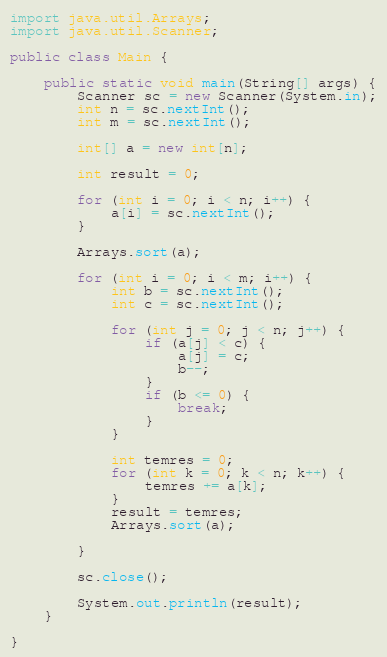Convert code to text. <code><loc_0><loc_0><loc_500><loc_500><_Java_>import java.util.Arrays;
import java.util.Scanner;

public class Main {

	public static void main(String[] args) {
		Scanner sc = new Scanner(System.in);
		int n = sc.nextInt();
		int m = sc.nextInt();

		int[] a = new int[n];

		int result = 0;

		for (int i = 0; i < n; i++) {
			a[i] = sc.nextInt();
		}

		Arrays.sort(a);

		for (int i = 0; i < m; i++) {
			int b = sc.nextInt();
			int c = sc.nextInt();

			for (int j = 0; j < n; j++) {
				if (a[j] < c) {
					a[j] = c;
					b--;
				}
				if (b <= 0) {
					break;
				}
			}

			int temres = 0;
			for (int k = 0; k < n; k++) {
				temres += a[k];
			}
			result = temres;
			Arrays.sort(a);

		}

		sc.close();

		System.out.println(result);
	}

}
</code> 